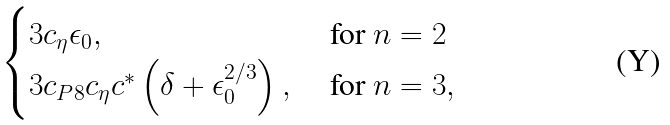<formula> <loc_0><loc_0><loc_500><loc_500>\begin{cases} 3 c _ { \eta } \epsilon _ { 0 } , & \text { for $n=2$} \\ 3 c _ { P 8 } c _ { \eta } c ^ { * } \left ( \delta + \epsilon _ { 0 } ^ { 2 / 3 } \right ) , & \text { for $n=3$} , \end{cases}</formula> 